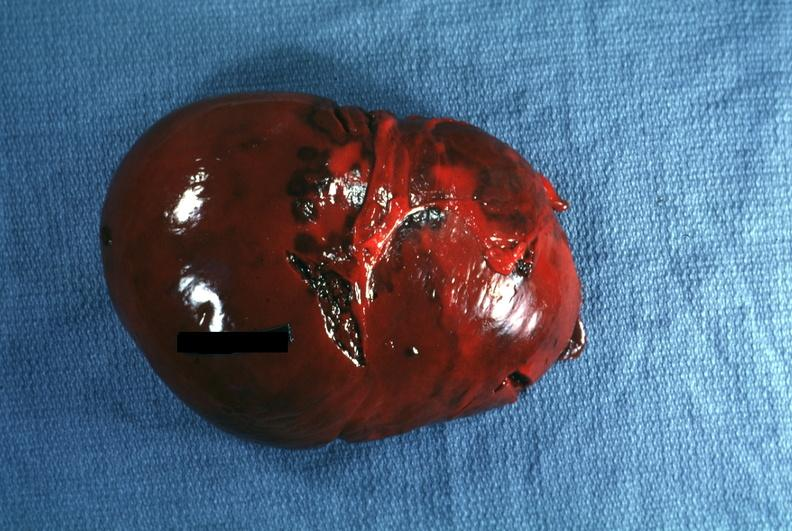s intramural one lesion present?
Answer the question using a single word or phrase. No 